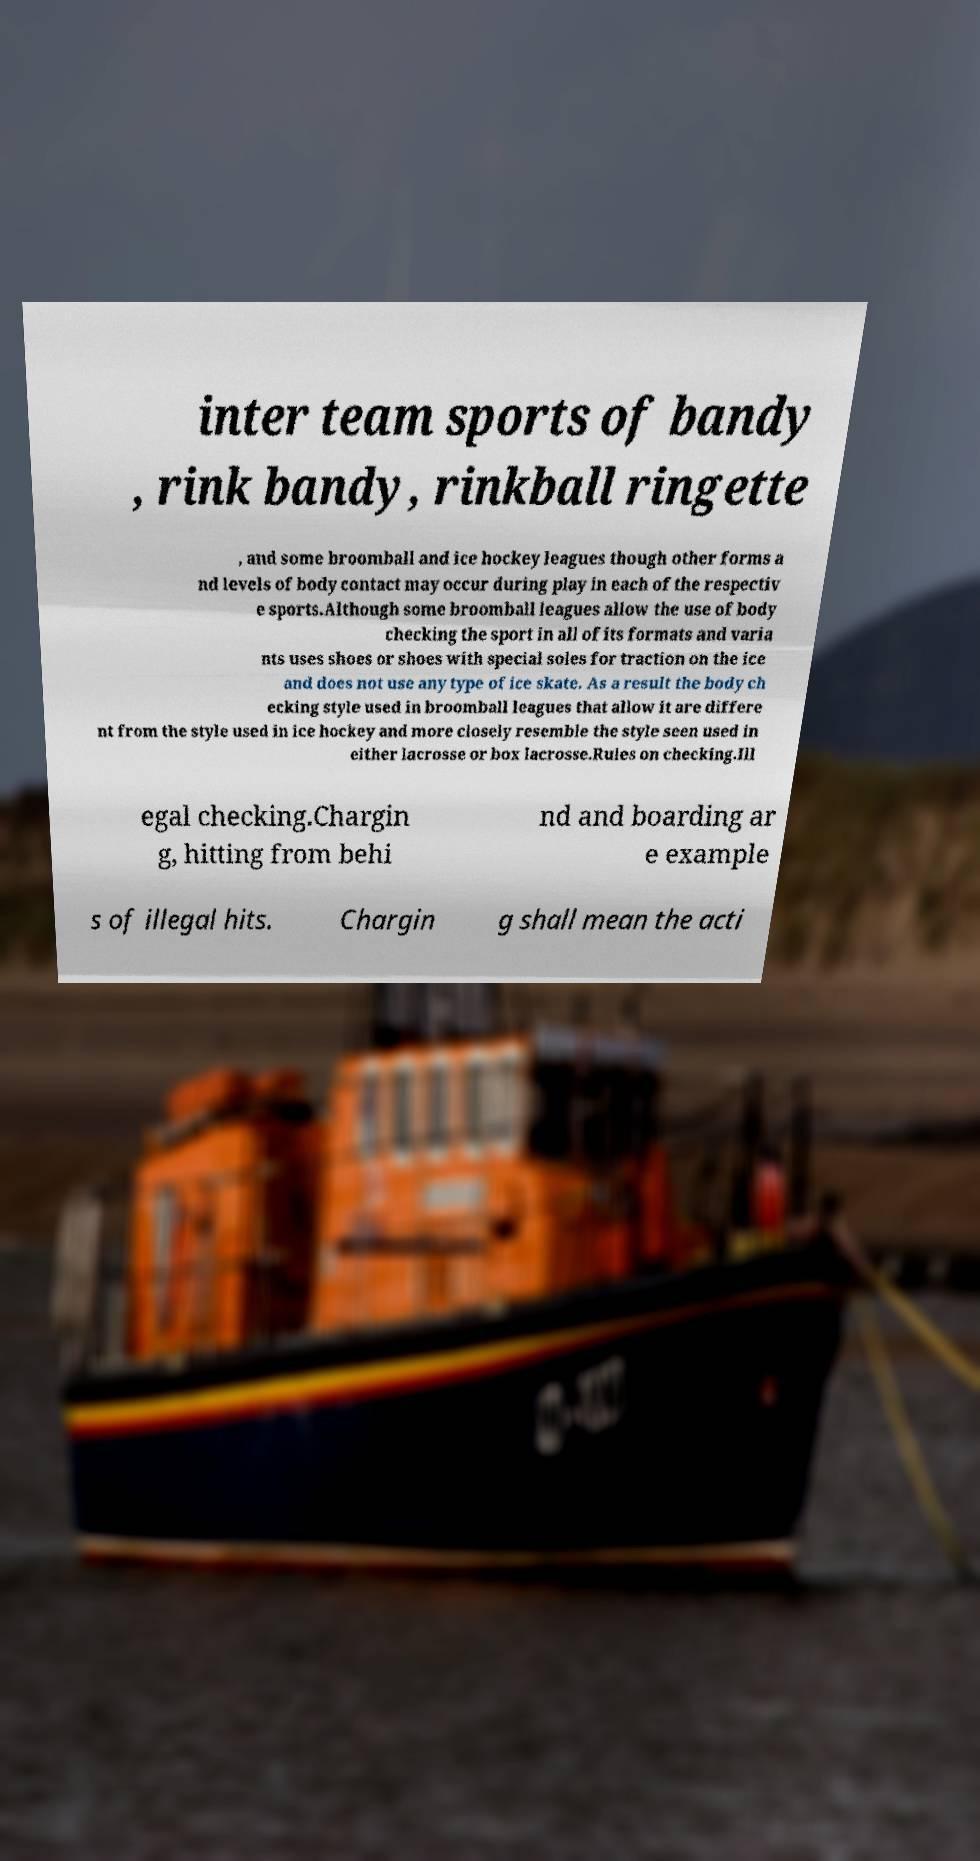What messages or text are displayed in this image? I need them in a readable, typed format. inter team sports of bandy , rink bandy, rinkball ringette , and some broomball and ice hockey leagues though other forms a nd levels of body contact may occur during play in each of the respectiv e sports.Although some broomball leagues allow the use of body checking the sport in all of its formats and varia nts uses shoes or shoes with special soles for traction on the ice and does not use any type of ice skate. As a result the body ch ecking style used in broomball leagues that allow it are differe nt from the style used in ice hockey and more closely resemble the style seen used in either lacrosse or box lacrosse.Rules on checking.Ill egal checking.Chargin g, hitting from behi nd and boarding ar e example s of illegal hits. Chargin g shall mean the acti 